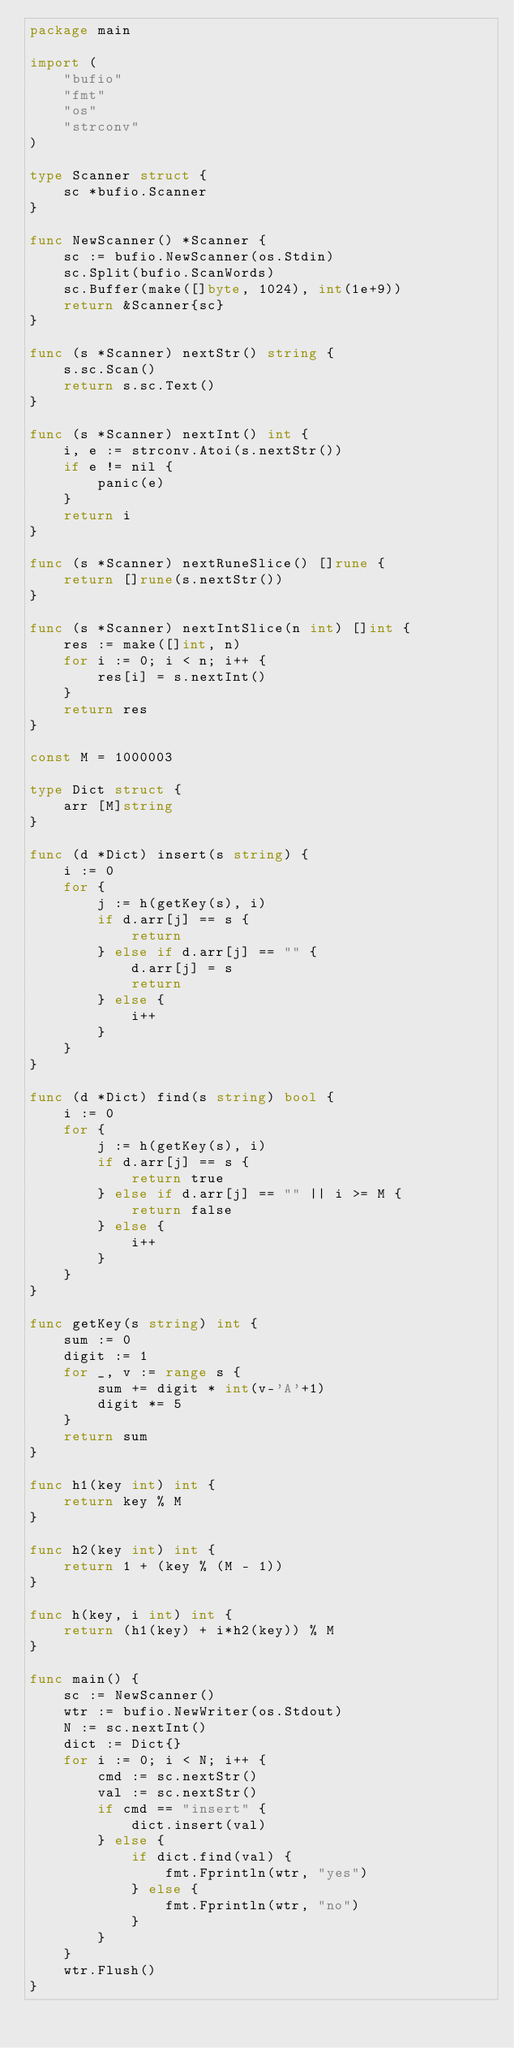Convert code to text. <code><loc_0><loc_0><loc_500><loc_500><_Go_>package main

import (
	"bufio"
	"fmt"
	"os"
	"strconv"
)

type Scanner struct {
	sc *bufio.Scanner
}

func NewScanner() *Scanner {
	sc := bufio.NewScanner(os.Stdin)
	sc.Split(bufio.ScanWords)
	sc.Buffer(make([]byte, 1024), int(1e+9))
	return &Scanner{sc}
}

func (s *Scanner) nextStr() string {
	s.sc.Scan()
	return s.sc.Text()
}

func (s *Scanner) nextInt() int {
	i, e := strconv.Atoi(s.nextStr())
	if e != nil {
		panic(e)
	}
	return i
}

func (s *Scanner) nextRuneSlice() []rune {
	return []rune(s.nextStr())
}

func (s *Scanner) nextIntSlice(n int) []int {
	res := make([]int, n)
	for i := 0; i < n; i++ {
		res[i] = s.nextInt()
	}
	return res
}

const M = 1000003

type Dict struct {
	arr [M]string
}

func (d *Dict) insert(s string) {
	i := 0
	for {
		j := h(getKey(s), i)
		if d.arr[j] == s {
			return
		} else if d.arr[j] == "" {
			d.arr[j] = s
			return
		} else {
			i++
		}
	}
}

func (d *Dict) find(s string) bool {
	i := 0
	for {
		j := h(getKey(s), i)
		if d.arr[j] == s {
			return true
		} else if d.arr[j] == "" || i >= M {
			return false
		} else {
			i++
		}
	}
}

func getKey(s string) int {
	sum := 0
	digit := 1
	for _, v := range s {
		sum += digit * int(v-'A'+1)
		digit *= 5
	}
	return sum
}

func h1(key int) int {
	return key % M
}

func h2(key int) int {
	return 1 + (key % (M - 1))
}

func h(key, i int) int {
	return (h1(key) + i*h2(key)) % M
}

func main() {
	sc := NewScanner()
	wtr := bufio.NewWriter(os.Stdout)
	N := sc.nextInt()
	dict := Dict{}
	for i := 0; i < N; i++ {
		cmd := sc.nextStr()
		val := sc.nextStr()
		if cmd == "insert" {
			dict.insert(val)
		} else {
			if dict.find(val) {
				fmt.Fprintln(wtr, "yes")
			} else {
				fmt.Fprintln(wtr, "no")
			}
		}
	}
	wtr.Flush()
}

</code> 